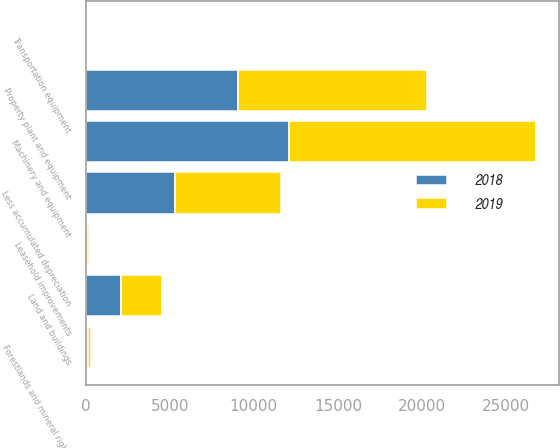Convert chart. <chart><loc_0><loc_0><loc_500><loc_500><stacked_bar_chart><ecel><fcel>Land and buildings<fcel>Machinery and equipment<fcel>Forestlands and mineral rights<fcel>Transportation equipment<fcel>Leasehold improvements<fcel>Less accumulated depreciation<fcel>Property plant and equipment<nl><fcel>2019<fcel>2442.3<fcel>14743.6<fcel>144<fcel>31.2<fcel>100.2<fcel>6271.8<fcel>11189.5<nl><fcel>2018<fcel>2078.9<fcel>12064<fcel>158<fcel>30.1<fcel>88.9<fcel>5337.4<fcel>9082.5<nl></chart> 